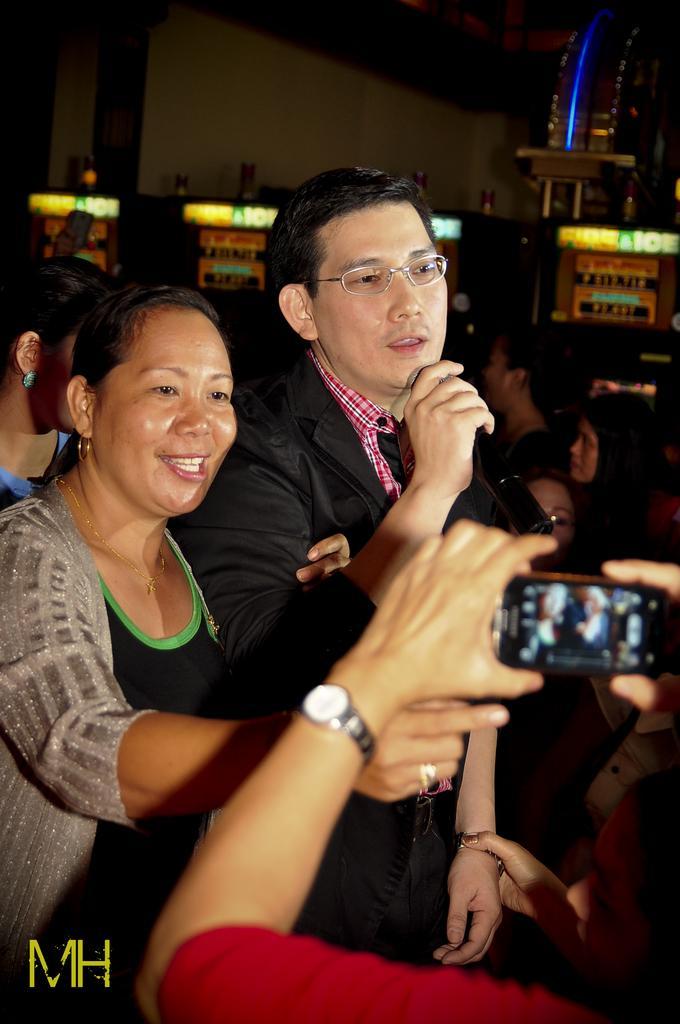Please provide a concise description of this image. Here we can see a couple of people standing in the middle and the person on the right is speaking something in the microphone present in his hand and in front of them there is person who is clicking pictures of them in the mobile phone present in their hand and behind them also we can see people present 